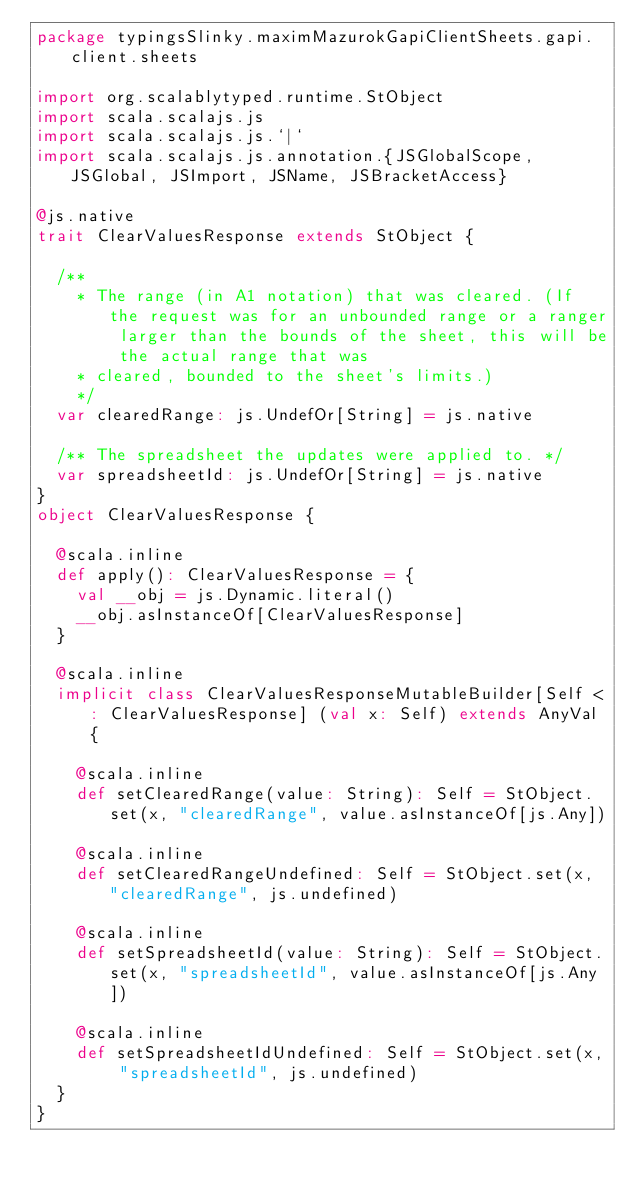Convert code to text. <code><loc_0><loc_0><loc_500><loc_500><_Scala_>package typingsSlinky.maximMazurokGapiClientSheets.gapi.client.sheets

import org.scalablytyped.runtime.StObject
import scala.scalajs.js
import scala.scalajs.js.`|`
import scala.scalajs.js.annotation.{JSGlobalScope, JSGlobal, JSImport, JSName, JSBracketAccess}

@js.native
trait ClearValuesResponse extends StObject {
  
  /**
    * The range (in A1 notation) that was cleared. (If the request was for an unbounded range or a ranger larger than the bounds of the sheet, this will be the actual range that was
    * cleared, bounded to the sheet's limits.)
    */
  var clearedRange: js.UndefOr[String] = js.native
  
  /** The spreadsheet the updates were applied to. */
  var spreadsheetId: js.UndefOr[String] = js.native
}
object ClearValuesResponse {
  
  @scala.inline
  def apply(): ClearValuesResponse = {
    val __obj = js.Dynamic.literal()
    __obj.asInstanceOf[ClearValuesResponse]
  }
  
  @scala.inline
  implicit class ClearValuesResponseMutableBuilder[Self <: ClearValuesResponse] (val x: Self) extends AnyVal {
    
    @scala.inline
    def setClearedRange(value: String): Self = StObject.set(x, "clearedRange", value.asInstanceOf[js.Any])
    
    @scala.inline
    def setClearedRangeUndefined: Self = StObject.set(x, "clearedRange", js.undefined)
    
    @scala.inline
    def setSpreadsheetId(value: String): Self = StObject.set(x, "spreadsheetId", value.asInstanceOf[js.Any])
    
    @scala.inline
    def setSpreadsheetIdUndefined: Self = StObject.set(x, "spreadsheetId", js.undefined)
  }
}
</code> 